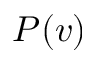<formula> <loc_0><loc_0><loc_500><loc_500>P ( v )</formula> 